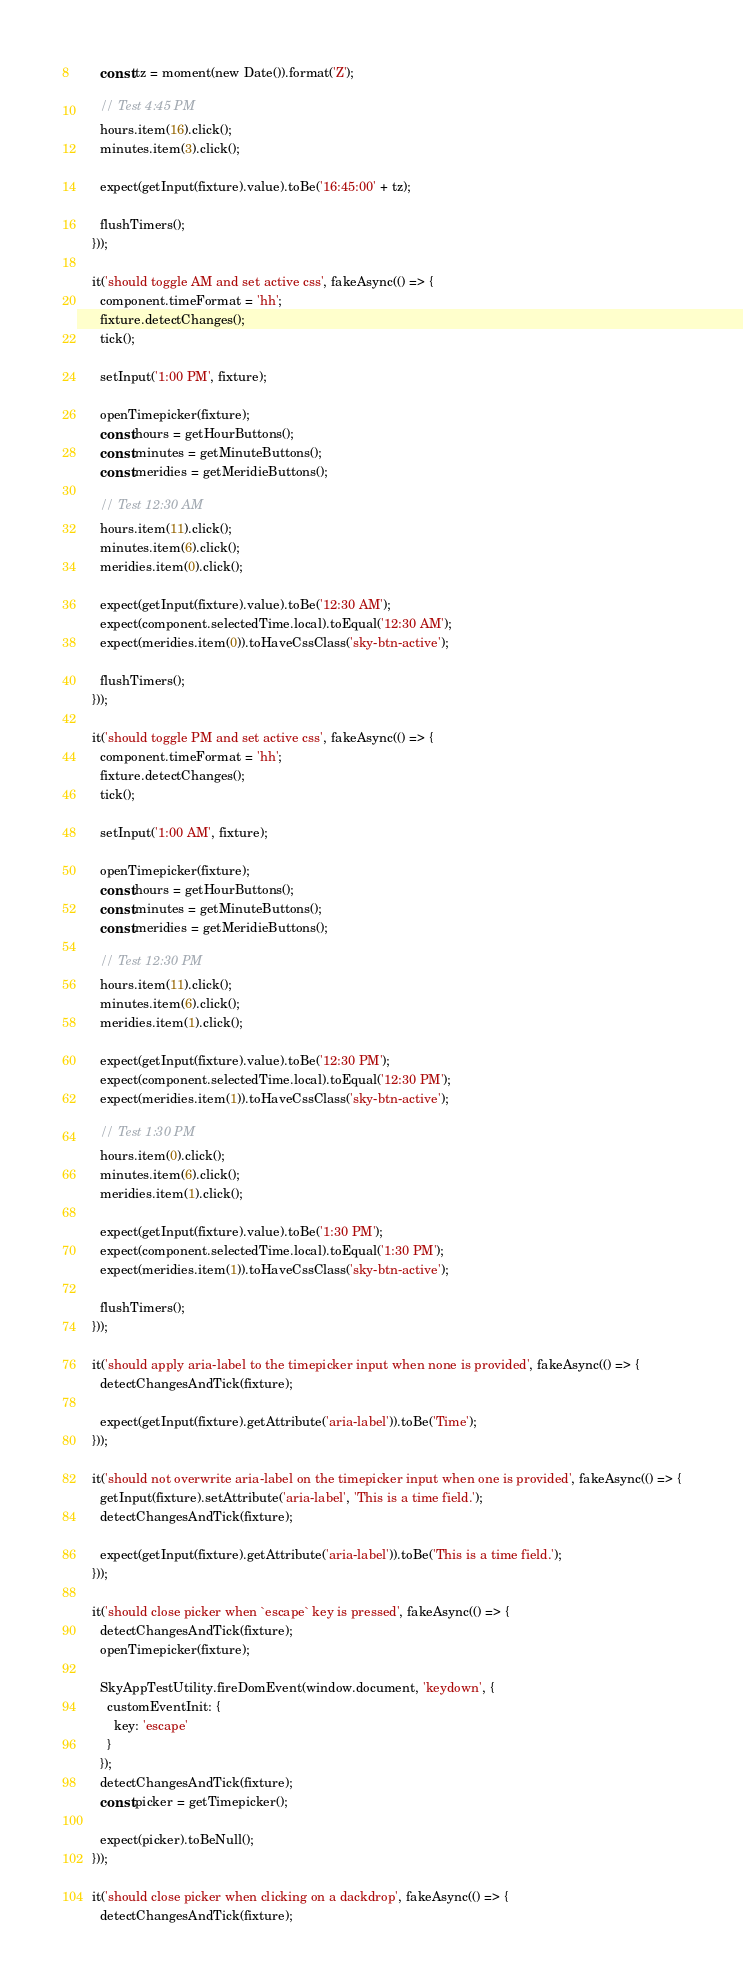Convert code to text. <code><loc_0><loc_0><loc_500><loc_500><_TypeScript_>      const tz = moment(new Date()).format('Z');

      // Test 4:45 PM
      hours.item(16).click();
      minutes.item(3).click();

      expect(getInput(fixture).value).toBe('16:45:00' + tz);

      flushTimers();
    }));

    it('should toggle AM and set active css', fakeAsync(() => {
      component.timeFormat = 'hh';
      fixture.detectChanges();
      tick();

      setInput('1:00 PM', fixture);

      openTimepicker(fixture);
      const hours = getHourButtons();
      const minutes = getMinuteButtons();
      const meridies = getMeridieButtons();

      // Test 12:30 AM
      hours.item(11).click();
      minutes.item(6).click();
      meridies.item(0).click();

      expect(getInput(fixture).value).toBe('12:30 AM');
      expect(component.selectedTime.local).toEqual('12:30 AM');
      expect(meridies.item(0)).toHaveCssClass('sky-btn-active');

      flushTimers();
    }));

    it('should toggle PM and set active css', fakeAsync(() => {
      component.timeFormat = 'hh';
      fixture.detectChanges();
      tick();

      setInput('1:00 AM', fixture);

      openTimepicker(fixture);
      const hours = getHourButtons();
      const minutes = getMinuteButtons();
      const meridies = getMeridieButtons();

      // Test 12:30 PM
      hours.item(11).click();
      minutes.item(6).click();
      meridies.item(1).click();

      expect(getInput(fixture).value).toBe('12:30 PM');
      expect(component.selectedTime.local).toEqual('12:30 PM');
      expect(meridies.item(1)).toHaveCssClass('sky-btn-active');

      // Test 1:30 PM
      hours.item(0).click();
      minutes.item(6).click();
      meridies.item(1).click();

      expect(getInput(fixture).value).toBe('1:30 PM');
      expect(component.selectedTime.local).toEqual('1:30 PM');
      expect(meridies.item(1)).toHaveCssClass('sky-btn-active');

      flushTimers();
    }));

    it('should apply aria-label to the timepicker input when none is provided', fakeAsync(() => {
      detectChangesAndTick(fixture);

      expect(getInput(fixture).getAttribute('aria-label')).toBe('Time');
    }));

    it('should not overwrite aria-label on the timepicker input when one is provided', fakeAsync(() => {
      getInput(fixture).setAttribute('aria-label', 'This is a time field.');
      detectChangesAndTick(fixture);

      expect(getInput(fixture).getAttribute('aria-label')).toBe('This is a time field.');
    }));

    it('should close picker when `escape` key is pressed', fakeAsync(() => {
      detectChangesAndTick(fixture);
      openTimepicker(fixture);

      SkyAppTestUtility.fireDomEvent(window.document, 'keydown', {
        customEventInit: {
          key: 'escape'
        }
      });
      detectChangesAndTick(fixture);
      const picker = getTimepicker();

      expect(picker).toBeNull();
    }));

    it('should close picker when clicking on a dackdrop', fakeAsync(() => {
      detectChangesAndTick(fixture);</code> 